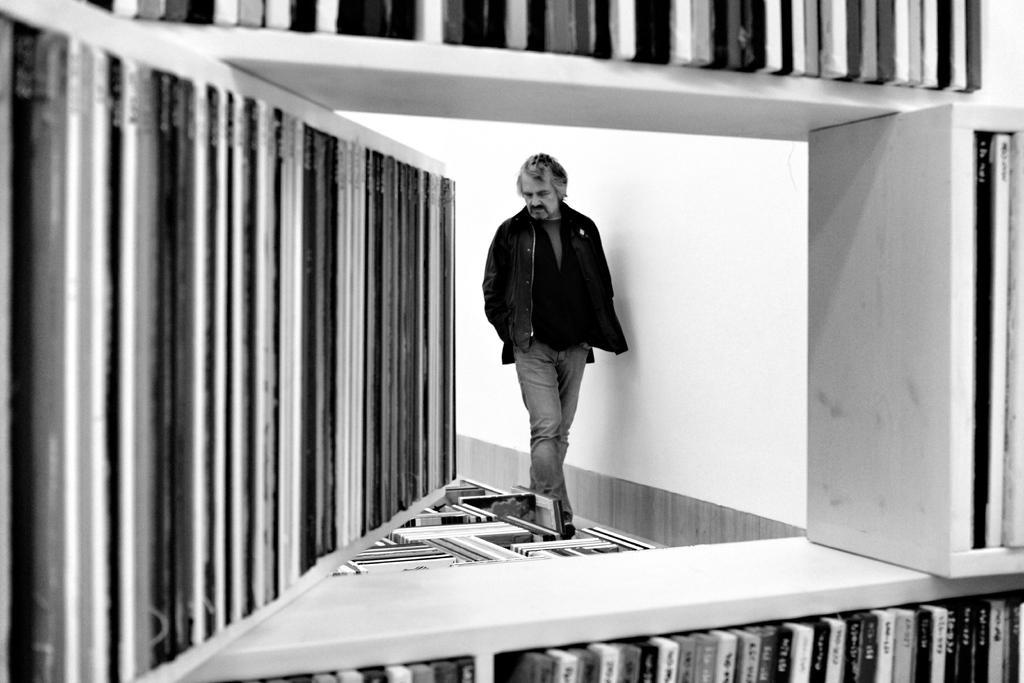How would you summarize this image in a sentence or two? In this image I can see in the middle a man is walking, he wore coat, trouser. At the bottom there are books in the rack. 